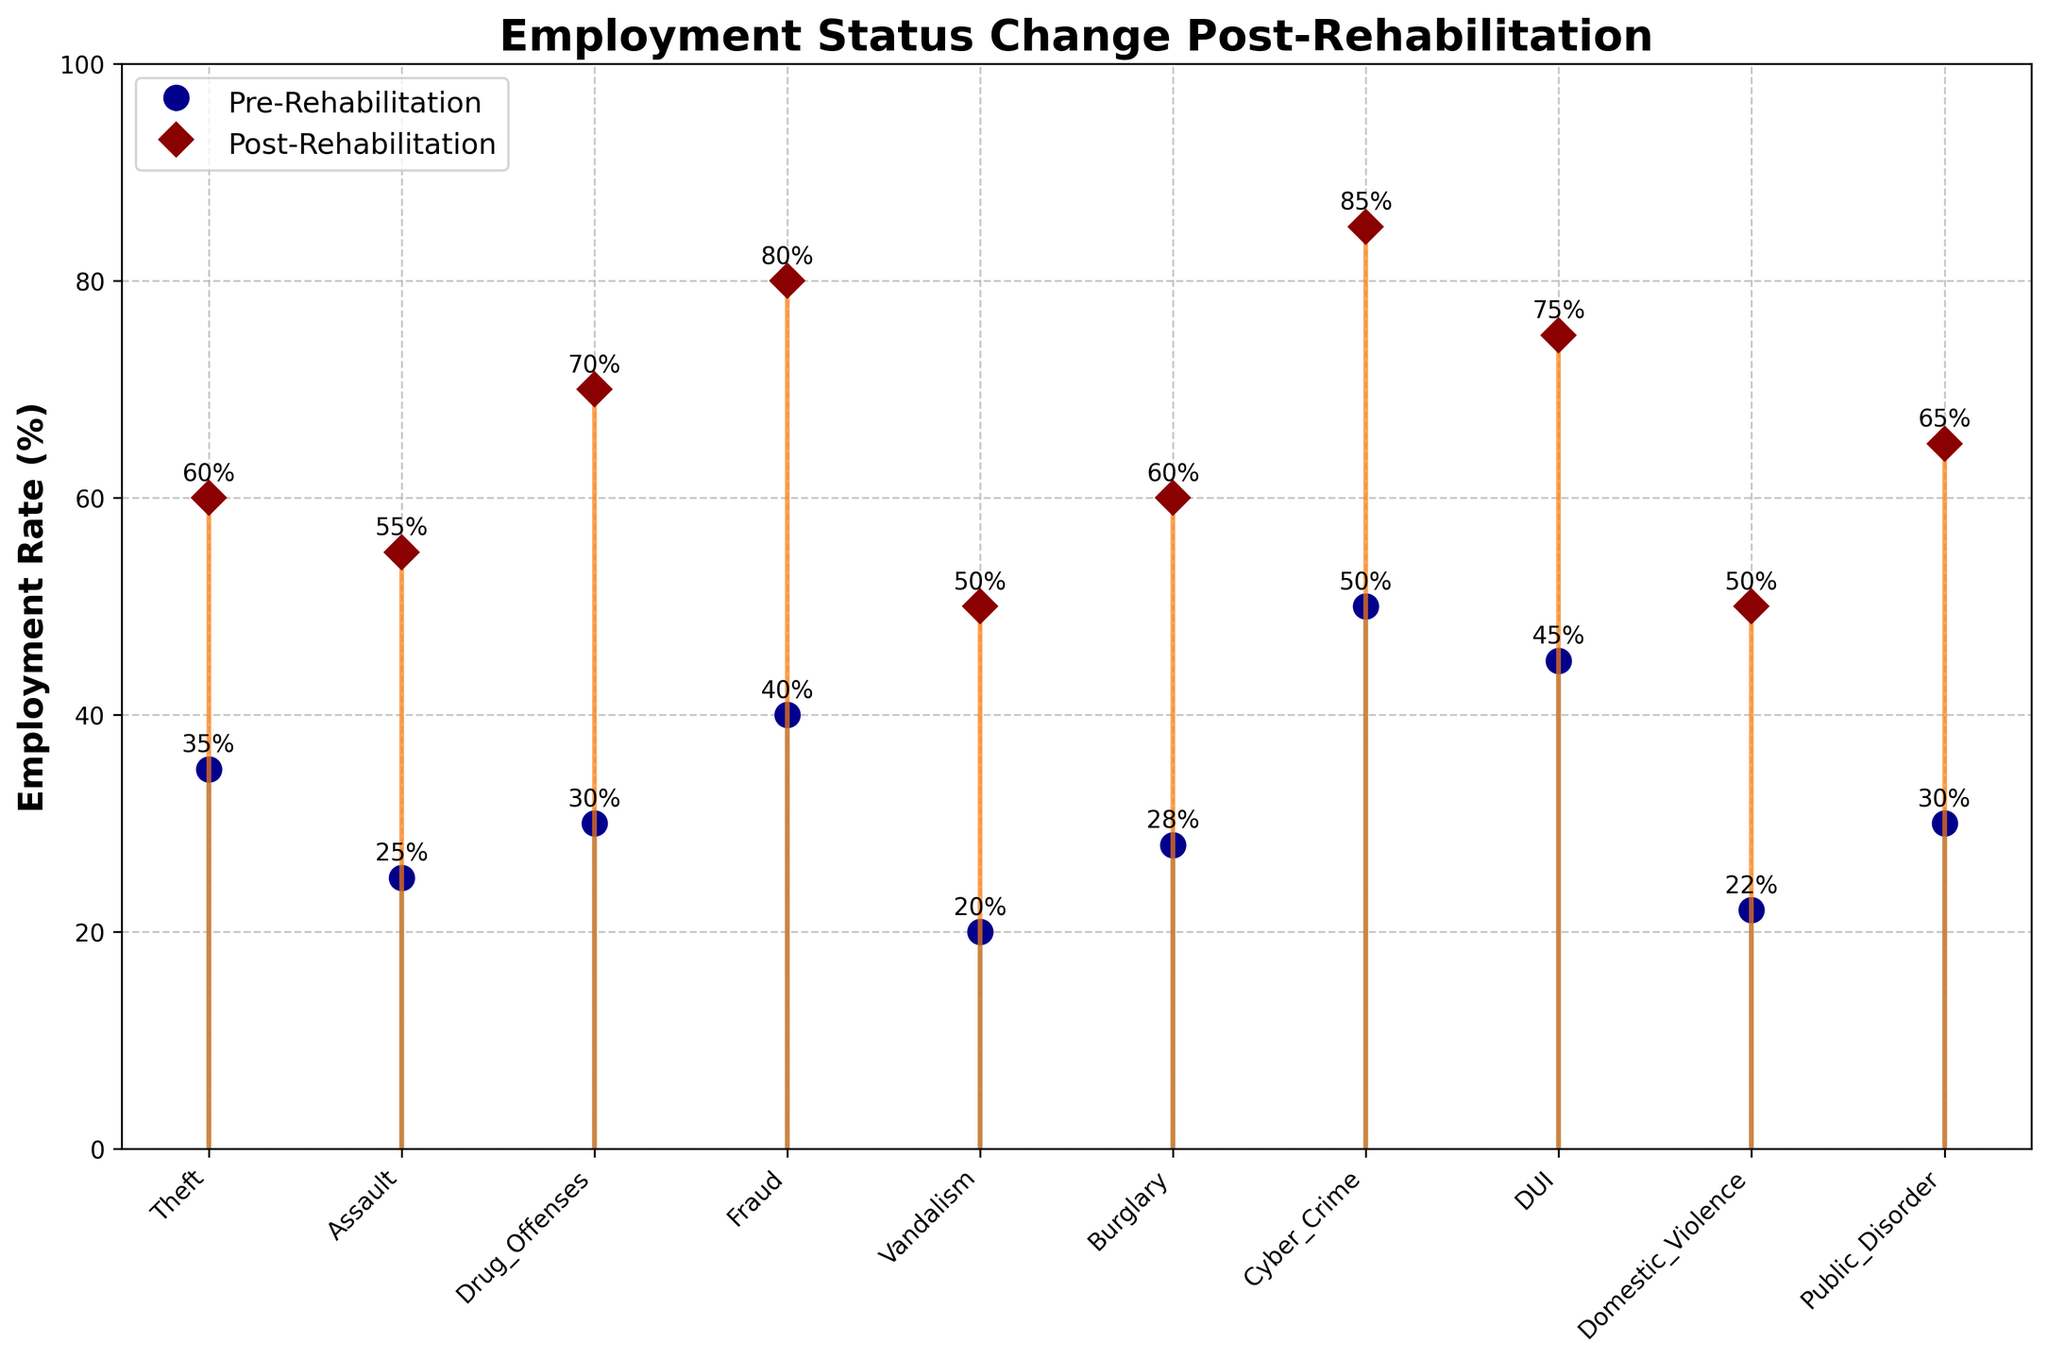How many offense types are shown in the figure? To find the number of offense types, count the labels on the x-axis. There are 10 different labels.
Answer: 10 What is the title of the figure? Read the title at the top of the figure. It states the main topic of the data.
Answer: Employment Status Change Post-Rehabilitation Which offense type has the highest post-rehabilitation employment rate? Look for the highest data point in the series labeled "Post-Rehabilitation" to find the offense type. Cyber Crime has the highest point at 85%.
Answer: Cyber Crime Which offense type saw the largest increase in employment rate post-rehabilitation? Compare the difference between pre-rehabilitation and post-rehabilitation rates for each offense type. Fraud increased from 40% to 80%, which is a 40% change.
Answer: Fraud What is the range of pre-rehabilitation employment rates in the figure? Identify the minimum and maximum values in the pre-rehabilitation series. The minimum is Vandalism at 20%, and the maximum is Cyber Crime at 50%. The range is 50 - 20.
Answer: 30% By how much did the employment rate change for Theft post-rehabilitation? Subtract the pre-rehabilitation rate of Theft from the post-rehabilitation rate: 60% - 35%.
Answer: 25% Which offense type had an employment rate of 45% pre-rehabilitation? Identify the offense type that has a pre-rehabilitation rate marker at 45%. This corresponds to DUI.
Answer: DUI What is the average post-rehabilitation employment rate across all offense types? Sum all post-rehabilitation rates and divide by the number of offense types: (60 + 55 + 70 + 80 + 50 + 60 + 85 + 75 + 50 + 65) / 10 = 65%
Answer: 65% Did any offense type have the same employment rate both pre- and post-rehabilitation? Check each pair of data points to see if any offense type remains unchanged. No offense type has the same rate.
Answer: No How does the employment improvement for Drug Offenses compare with Burglary? For Drug Offenses, the change is 70% - 30% = 40%. For Burglary, the change is 60% - 28% = 32%. Drug Offenses had a greater improvement.
Answer: Drug Offenses had a greater improvement 